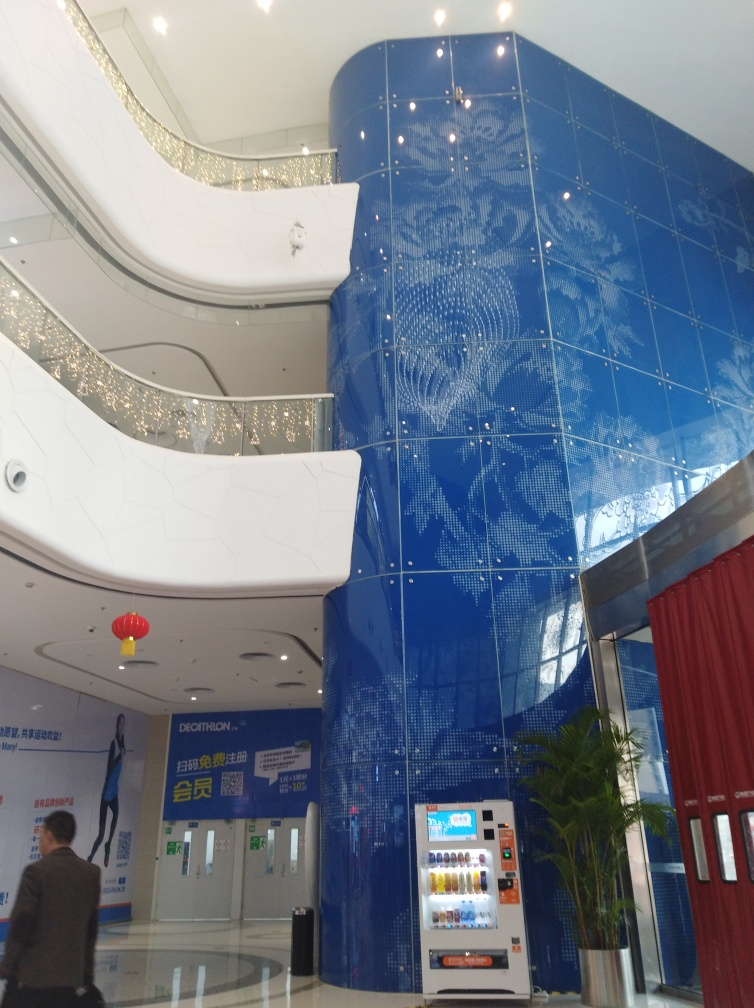Is the architectural style the main subject in the image?
 Yes 